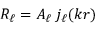Convert formula to latex. <formula><loc_0><loc_0><loc_500><loc_500>R _ { \ell } = A _ { \ell } \, j _ { \ell } ( k r )</formula> 